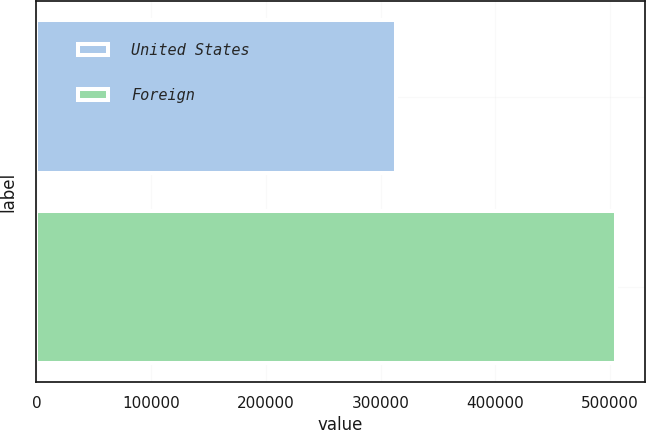Convert chart. <chart><loc_0><loc_0><loc_500><loc_500><bar_chart><fcel>United States<fcel>Foreign<nl><fcel>313178<fcel>505151<nl></chart> 